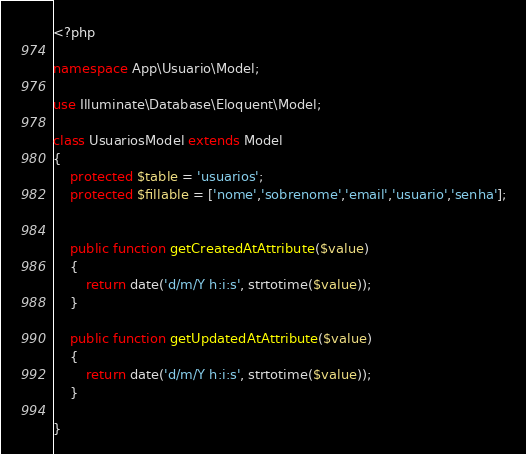Convert code to text. <code><loc_0><loc_0><loc_500><loc_500><_PHP_><?php

namespace App\Usuario\Model;

use Illuminate\Database\Eloquent\Model;

class UsuariosModel extends Model
{   
    protected $table = 'usuarios';
    protected $fillable = ['nome','sobrenome','email','usuario','senha'];
    
    
    public function getCreatedAtAttribute($value)
    {
        return date('d/m/Y h:i:s', strtotime($value));
    }
    
    public function getUpdatedAtAttribute($value)
    {
        return date('d/m/Y h:i:s', strtotime($value));
    }
    
}
</code> 